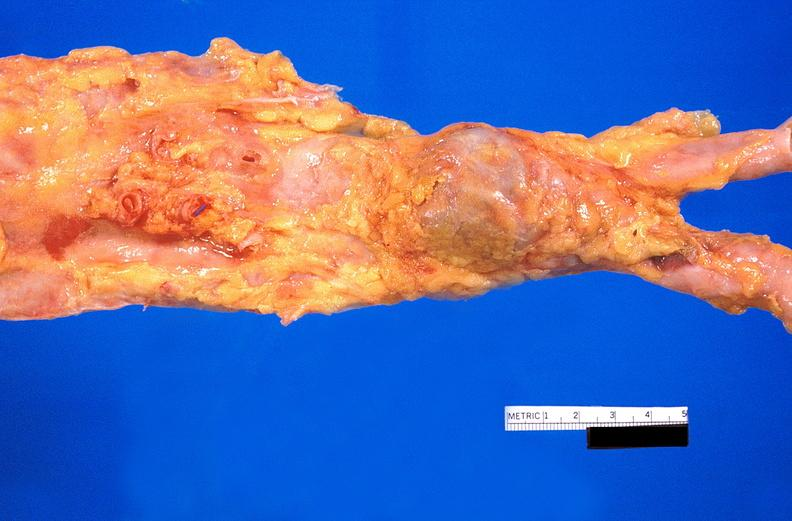does this image show abdominal aorta, atherosclerosis and fusiform aneurysm?
Answer the question using a single word or phrase. Yes 